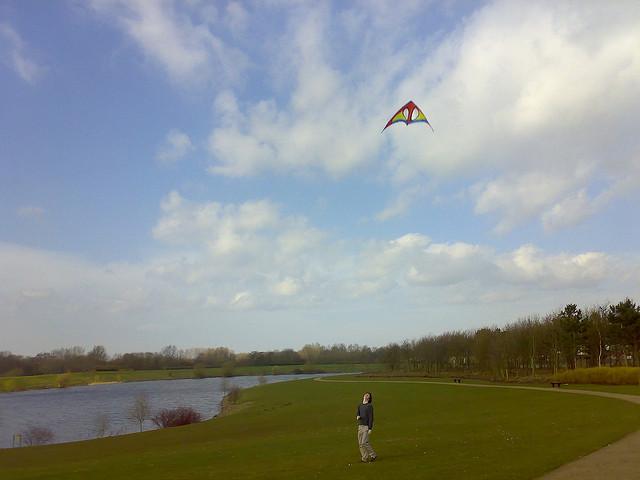Does the sky have many clouds today?
Short answer required. Yes. Is the kite on the right or left side of the man in the photo?
Be succinct. Right. Does the weather appear rainy?
Be succinct. No. Is this person in mid air?
Short answer required. No. What surface is he playing on?
Concise answer only. Grass. How many boats are in the water?
Keep it brief. 0. Is there a lake in the scene?
Keep it brief. Yes. How many kites are in the sky?
Answer briefly. 1. How many kites do you see?
Be succinct. 1. Does this park need more ducks?
Write a very short answer. Yes. What is the stretch of pavement on the right called?
Answer briefly. Sidewalk. What is in the air?
Be succinct. Kite. How many little girls can be seen?
Write a very short answer. 0. Is there a boat on the water?
Keep it brief. No. How old is the man in the picture?
Be succinct. 30. What connects the kite to the person?
Be succinct. String. What is the weather like?
Write a very short answer. Cloudy. What kind of trees are in the background?
Give a very brief answer. Pine. What color is the thing in the sky?
Short answer required. Multi. What season is shown in the picture?
Write a very short answer. Fall. What type of land is next to the grass?
Quick response, please. Pond. Is the person skateboarding?
Short answer required. No. Is the person moving?
Give a very brief answer. No. Is this person in motion?
Give a very brief answer. No. Does this appear to be a park?
Give a very brief answer. Yes. 